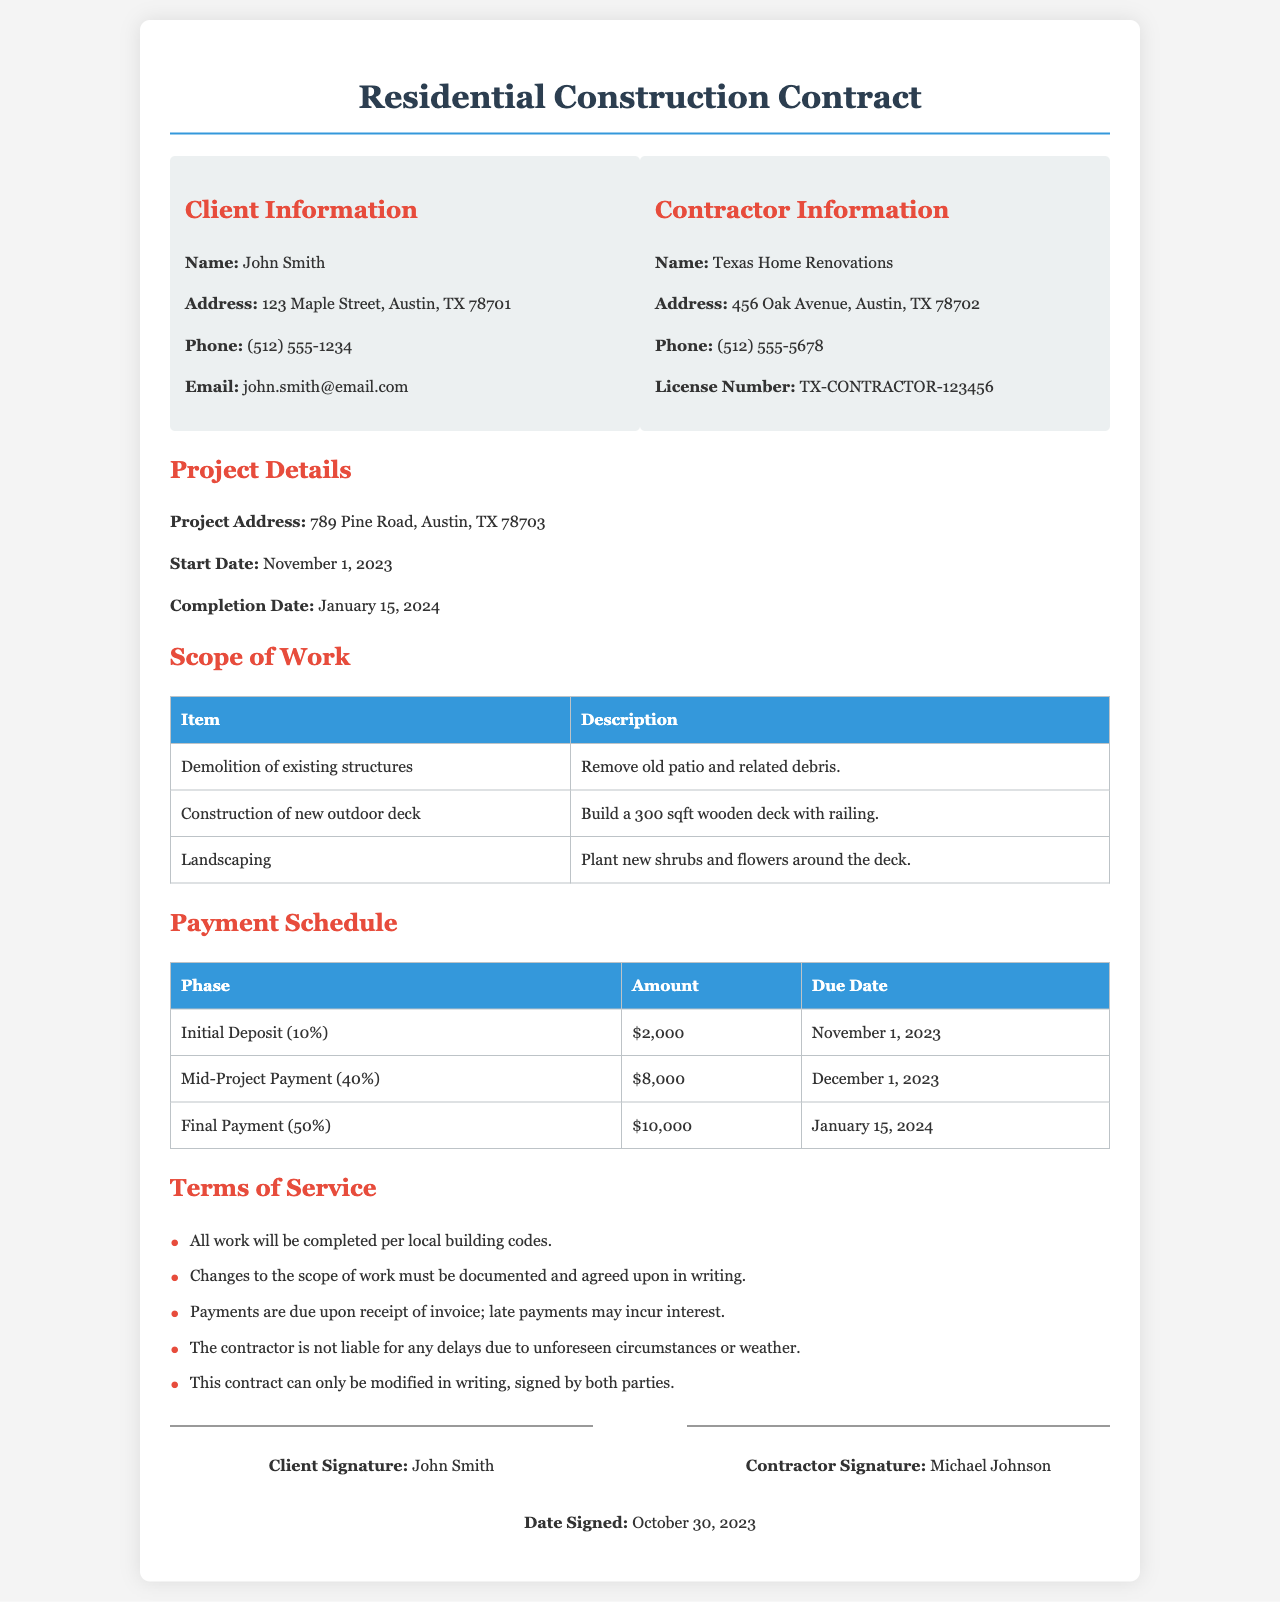What is the client's name? The client's name is clearly stated in the document under the Client Information section.
Answer: John Smith What is the contractor's license number? The contractor's license number is provided in the Contractor Information section.
Answer: TX-CONTRACTOR-123456 What is the start date of the project? The start date is listed under the Project Details section.
Answer: November 1, 2023 How much is the initial deposit? The amount for the initial deposit is specified in the Payment Schedule table.
Answer: $2,000 What is the total amount of the final payment? The total amount of the final payment is given in the Payment Schedule section.
Answer: $10,000 What must happen for changes to the scope of work? This requirement is found in the Terms of Service section of the document.
Answer: Documented and agreed upon in writing What are the consequences of late payments? The document states what happens with late payments in the Terms of Service section.
Answer: May incur interest When will the project be completed? The completion date is mentioned in the Project Details section.
Answer: January 15, 2024 What is the address of the project? The project address is specified in the Project Details section.
Answer: 789 Pine Road, Austin, TX 78703 